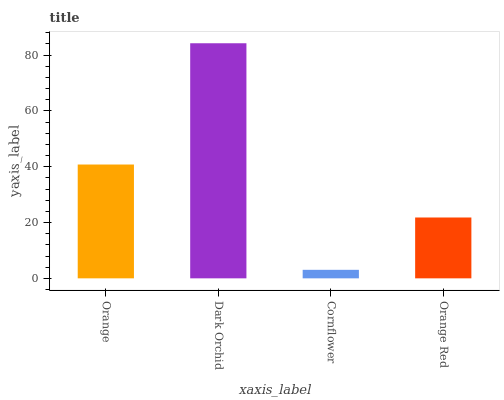Is Cornflower the minimum?
Answer yes or no. Yes. Is Dark Orchid the maximum?
Answer yes or no. Yes. Is Dark Orchid the minimum?
Answer yes or no. No. Is Cornflower the maximum?
Answer yes or no. No. Is Dark Orchid greater than Cornflower?
Answer yes or no. Yes. Is Cornflower less than Dark Orchid?
Answer yes or no. Yes. Is Cornflower greater than Dark Orchid?
Answer yes or no. No. Is Dark Orchid less than Cornflower?
Answer yes or no. No. Is Orange the high median?
Answer yes or no. Yes. Is Orange Red the low median?
Answer yes or no. Yes. Is Orange Red the high median?
Answer yes or no. No. Is Orange the low median?
Answer yes or no. No. 